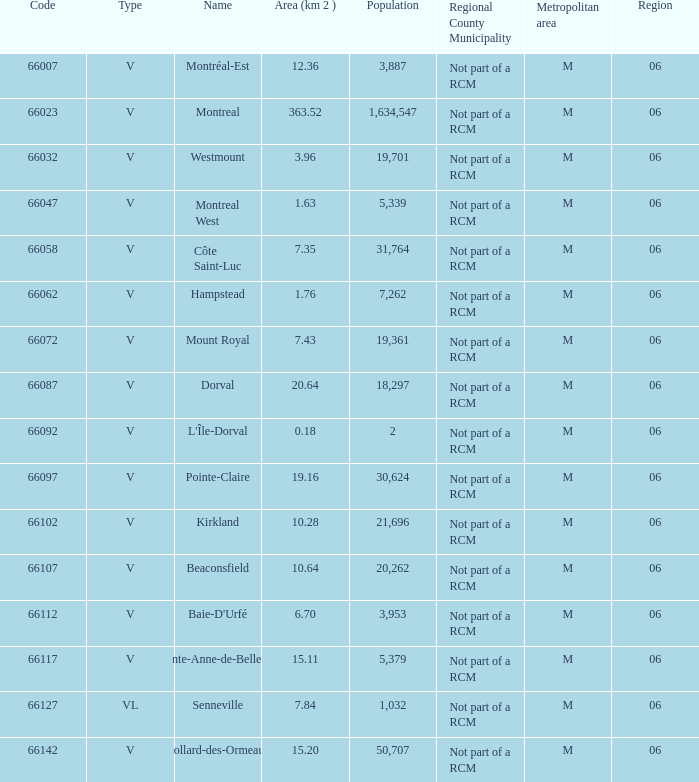What is the largest region with a code of 66097, and an area larger than 6? None. 